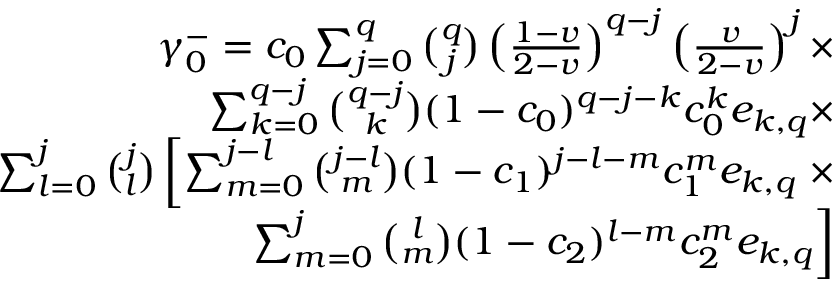Convert formula to latex. <formula><loc_0><loc_0><loc_500><loc_500>\begin{array} { r } { \gamma _ { 0 } ^ { - } = c _ { 0 } \sum _ { j = 0 } ^ { q } { \binom { q } { j } } \left ( \frac { 1 - v } { 2 - v } \right ) ^ { q - j } \left ( \frac { v } { 2 - v } \right ) ^ { j } \times } \\ { \sum _ { k = 0 } ^ { q - j } { \binom { q - j } { k } } ( 1 - c _ { 0 } ) ^ { q - j - k } c _ { 0 } ^ { k } e _ { k , q } \times } \\ { \sum _ { l = 0 } ^ { j } { \binom { j } { l } } \left [ \sum _ { m = 0 } ^ { j - l } { \binom { j - l } { m } } ( 1 - c _ { 1 } ) ^ { j - l - m } c _ { 1 } ^ { m } e _ { k , q } \times } \\ { \sum _ { m = 0 } ^ { j } { \binom { l } { m } } ( 1 - c _ { 2 } ) ^ { l - m } c _ { 2 } ^ { m } e _ { k , q } \right ] } \end{array}</formula> 